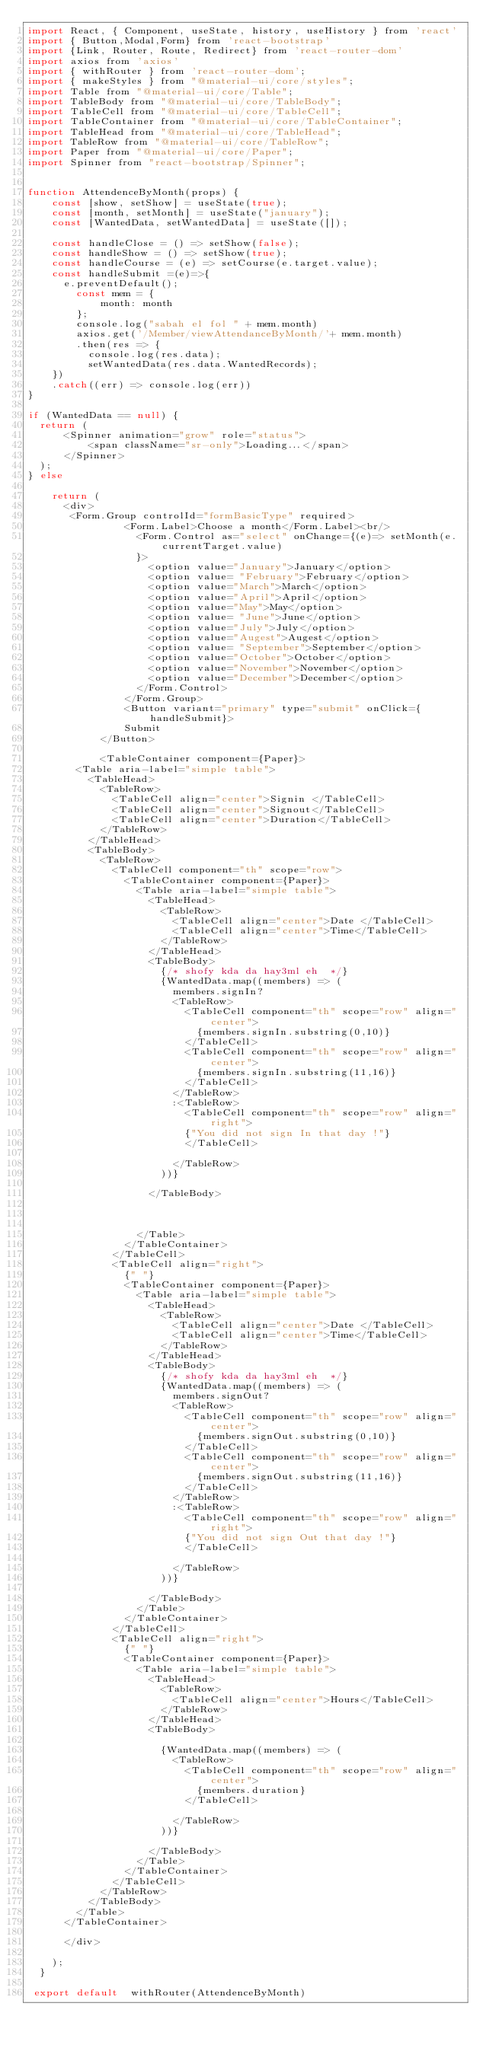Convert code to text. <code><loc_0><loc_0><loc_500><loc_500><_JavaScript_>import React, { Component, useState, history, useHistory } from 'react'
import { Button,Modal,Form} from 'react-bootstrap'
import {Link, Router, Route, Redirect} from 'react-router-dom'
import axios from 'axios'
import { withRouter } from 'react-router-dom';
import { makeStyles } from "@material-ui/core/styles";
import Table from "@material-ui/core/Table";
import TableBody from "@material-ui/core/TableBody";
import TableCell from "@material-ui/core/TableCell";
import TableContainer from "@material-ui/core/TableContainer";
import TableHead from "@material-ui/core/TableHead";
import TableRow from "@material-ui/core/TableRow";
import Paper from "@material-ui/core/Paper";
import Spinner from "react-bootstrap/Spinner";


function AttendenceByMonth(props) {
    const [show, setShow] = useState(true);
    const [month, setMonth] = useState("january");
    const [WantedData, setWantedData] = useState([]);
 
    const handleClose = () => setShow(false);
    const handleShow = () => setShow(true);
    const handleCourse = (e) => setCourse(e.target.value);
    const handleSubmit =(e)=>{
      e.preventDefault();
        const mem = {
            month: month
        };
        console.log("sabah el fol " + mem.month)
        axios.get('/Member/viewAttendanceByMonth/'+ mem.month)
        .then(res => {
          console.log(res.data);
          setWantedData(res.data.WantedRecords);
    })
    .catch((err) => console.log(err))
}
     
if (WantedData == null) {
  return (
      <Spinner animation="grow" role="status">
          <span className="sr-only">Loading...</span>
      </Spinner>
  );
} else
  
    return (
      <div>
       <Form.Group controlId="formBasicType" required>
                <Form.Label>Choose a month</Form.Label><br/>
                  <Form.Control as="select" onChange={(e)=> setMonth(e.currentTarget.value)
                  }>
                    <option value="January">January</option>
                    <option value= "February">February</option>
                    <option value="March">March</option>
                    <option value="April">April</option>
                    <option value="May">May</option>
                    <option value= "June">June</option>
                    <option value="July">July</option>
                    <option value="Augest">Augest</option>
                    <option value= "September">September</option>
                    <option value="October">October</option>
                    <option value="November">November</option>
                    <option value="December">December</option>
                  </Form.Control>
                </Form.Group>
                <Button variant="primary" type="submit" onClick={handleSubmit}>
                Submit
            </Button>

            <TableContainer component={Paper}>
				<Table aria-label="simple table">
					<TableHead>
						<TableRow>
							<TableCell align="center">Signin </TableCell>
							<TableCell align="center">Signout</TableCell>
							<TableCell align="center">Duration</TableCell>
						</TableRow>
					</TableHead>
					<TableBody>
						<TableRow>
							<TableCell component="th" scope="row">
								<TableContainer component={Paper}>
									<Table aria-label="simple table">
										<TableHead>
											<TableRow>
												<TableCell align="center">Date </TableCell>
												<TableCell align="center">Time</TableCell>
											</TableRow>
										</TableHead>
										<TableBody>
											{/* shofy kda da hay3ml eh  */}
                      {WantedData.map((members) => (
												members.signIn?
												<TableRow>
													<TableCell component="th" scope="row" align="center">
														{members.signIn.substring(0,10)}
													</TableCell>
													<TableCell component="th" scope="row" align="center">
														{members.signIn.substring(11,16)}
													</TableCell>
												</TableRow>
												:<TableRow>
													<TableCell component="th" scope="row" align="right">
													{"You did not sign In that day !"}
													</TableCell>
													
												</TableRow>
											))}

										</TableBody>

										
										
									</Table>
								</TableContainer>
							</TableCell>
							<TableCell align="right">
								{" "}
								<TableContainer component={Paper}>
									<Table aria-label="simple table">
										<TableHead>
											<TableRow>
												<TableCell align="center">Date </TableCell>
												<TableCell align="center">Time</TableCell>
											</TableRow>
										</TableHead>
										<TableBody>
											{/* shofy kda da hay3ml eh  */}
											{WantedData.map((members) => (
												members.signOut?
												<TableRow>
													<TableCell component="th" scope="row" align="center">
														{members.signOut.substring(0,10)}
													</TableCell>
													<TableCell component="th" scope="row" align="center">
														{members.signOut.substring(11,16)}
													</TableCell>
												</TableRow>
												:<TableRow>
													<TableCell component="th" scope="row" align="right">
													{"You did not sign Out that day !"}
													</TableCell>
													
												</TableRow>
											))}

										</TableBody>
									</Table>
								</TableContainer>
							</TableCell>
							<TableCell align="right">
								{" "}
								<TableContainer component={Paper}>
									<Table aria-label="simple table">
										<TableHead>
											<TableRow>
												<TableCell align="center">Hours</TableCell>
											</TableRow>
										</TableHead>
										<TableBody>
											
											{WantedData.map((members) => (
												<TableRow>
													<TableCell component="th" scope="row" align="center">
														{members.duration}
													</TableCell>
													
												</TableRow>
											))}
											
										</TableBody>
									</Table>
								</TableContainer>
							</TableCell>
						</TableRow>
					</TableBody>
				</Table>
			</TableContainer>

      </div>
     
    );
  }
  
 export default  withRouter(AttendenceByMonth)</code> 